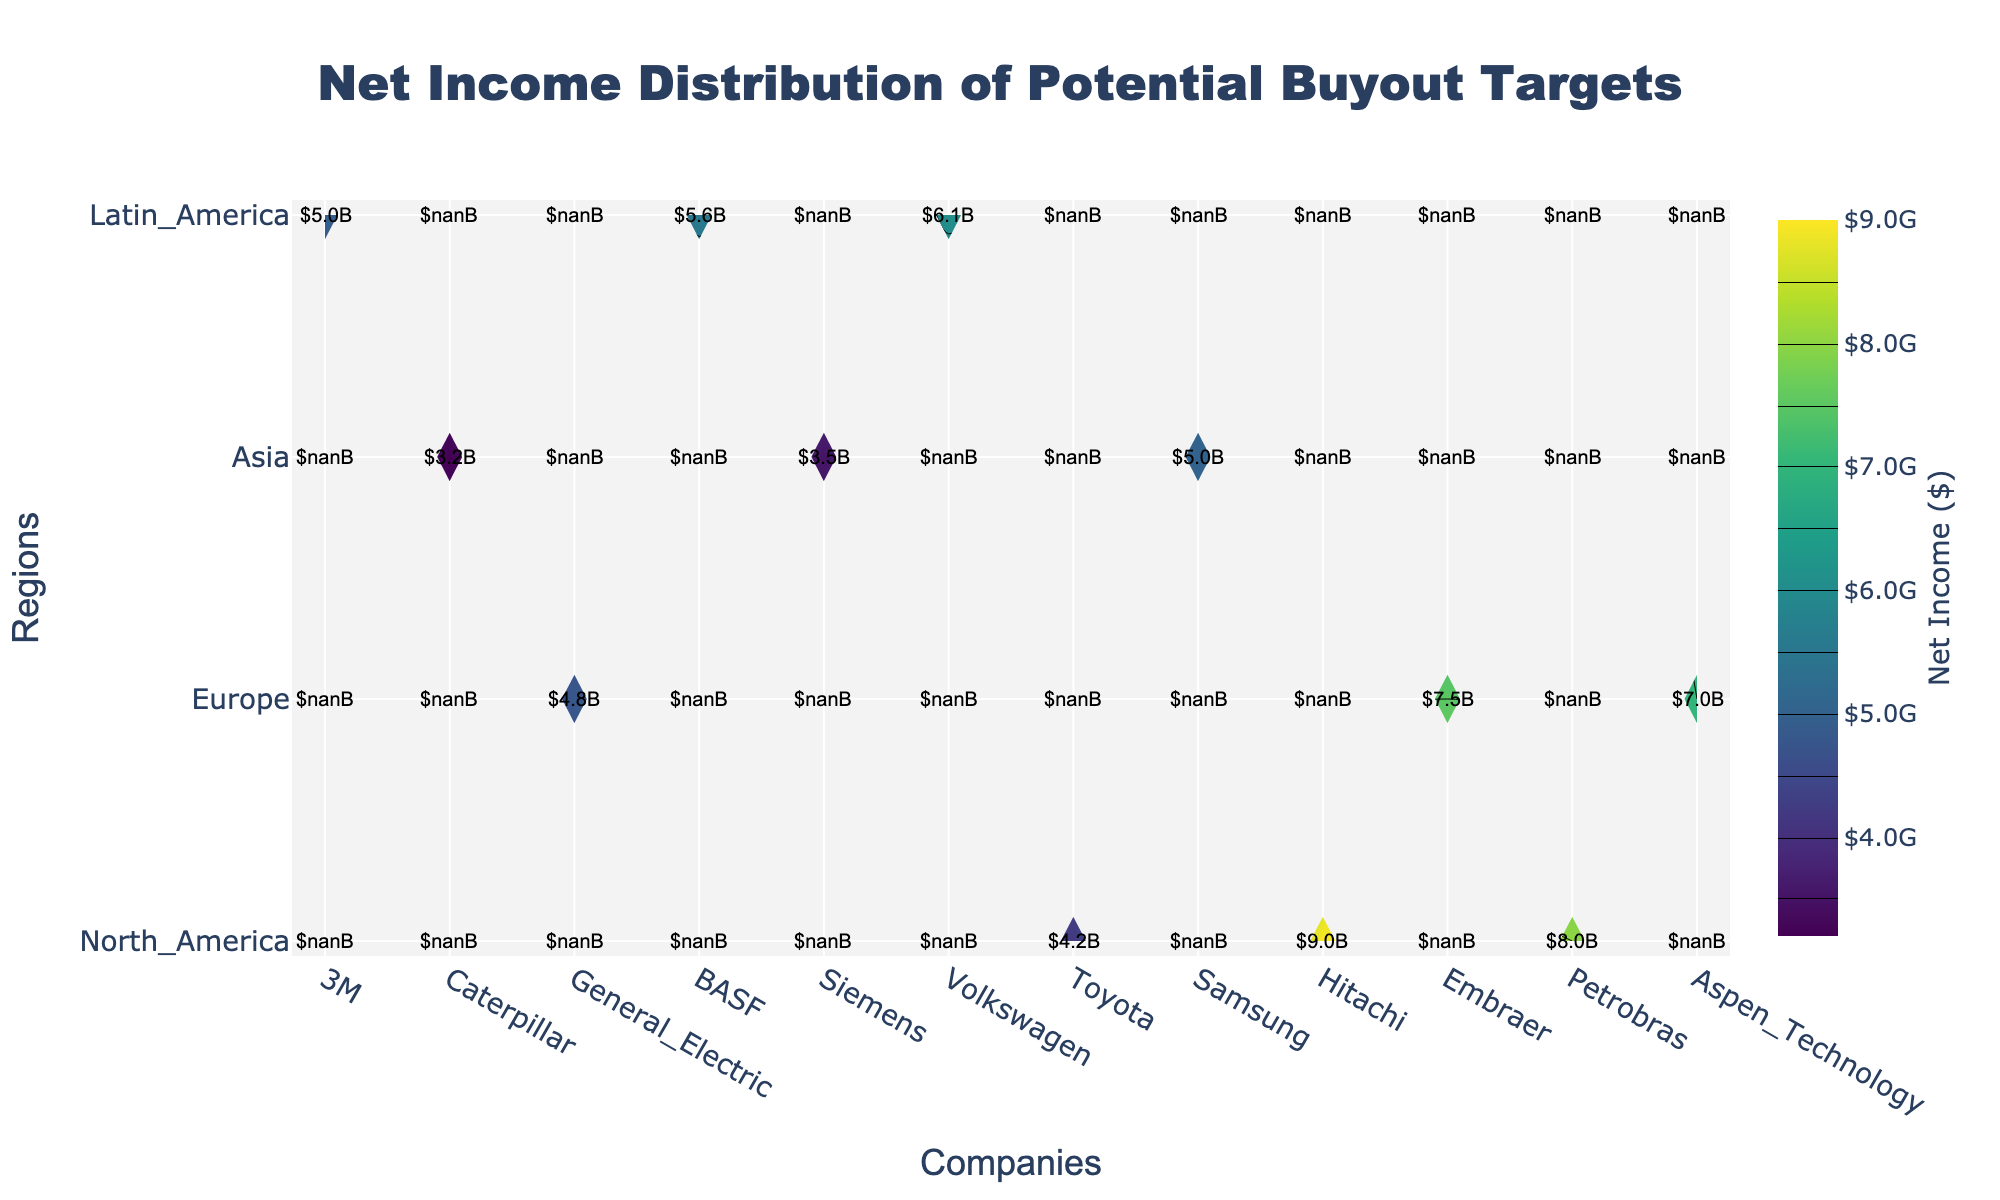What is the title of the figure? The title is typically located at the top-center of the plot. By referring to it, we identify the overall subject being illustrated.
Answer: Net Income Distribution of Potential Buyout Targets What does the color scale represent on the contour plot? The color scale, often placed on the right side, indicates the variable being represented, in this case, net income. The legend specifies it in terms of currency.
Answer: Net Income ($) Which company has the highest net income in Europe? Locate the Europe region on the y-axis and compare the contour levels, annotations, or labels of companies such as BASF, Siemens, and Volkswagen.
Answer: Siemens How many regions are represented in the plot? Identify the unique entries on the y-axis, each marking a different region (North America, Europe, Asia, Latin America). Count these visible entries.
Answer: 4 What is the net income value of General Electric in North America? Find General Electric on the x-axis and North America on the y-axis; intersect these coordinates to read the annotated net income value.
Answer: $6.1B Which company in the Latin America region shows the lowest net income? Look at the Latin America region on the y-axis, compare the net income values of Embraer, Petrobras, and Aspen Technology through contour labels.
Answer: Aspen Technology Compare the net incomes of Toyota and Samsung in Asia. Which is greater and by how much? Locate Toyota and Samsung on the x-axis within the Asia region on the y-axis. Note their net incomes and subtract Toyota's value from Samsung's.
Answer: Samsung is greater by $1B What is the average net income of all companies in Europe? Sum the net incomes of BASF, Siemens, and Volkswagen in the Europe region and divide by the number of companies (3).
Answer: ($4.8B + $7.5B + $7.0B) / 3 = $6.43B Which region shows the greatest variability in net income among its companies? Compare the range (difference between highest and lowest net incomes) within each region: North America, Europe, Asia, and Latin America. Consider the company extremes in each region.
Answer: Europe In which region does the company with the single highest net income reside? Identify the company with the highest net income value by checking all regions, then note this company's corresponding region.
Answer: Asia 